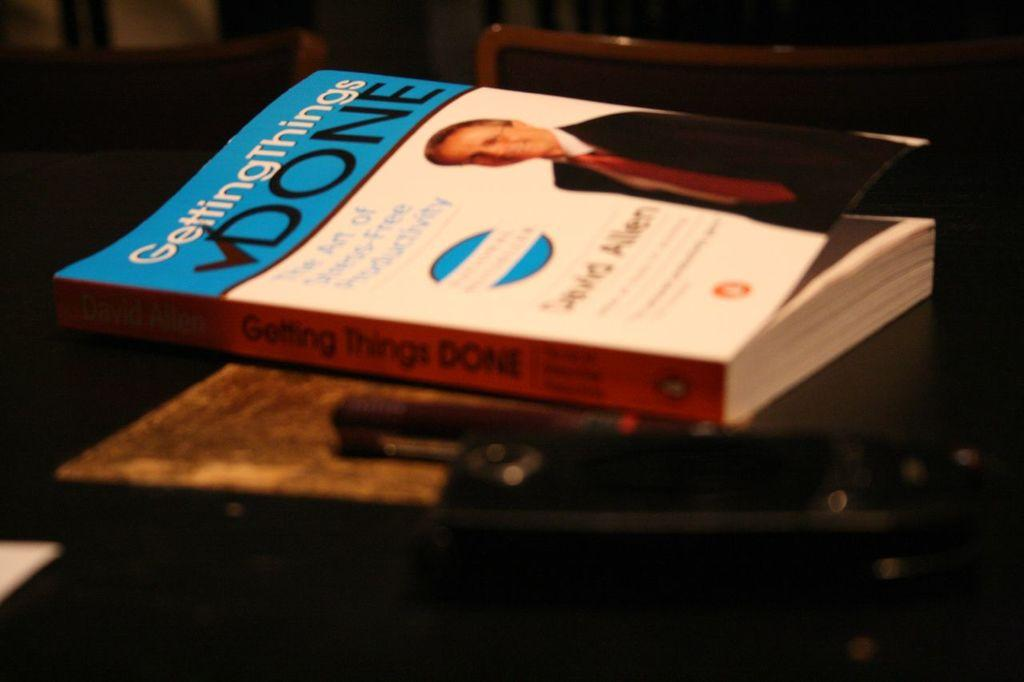Provide a one-sentence caption for the provided image. "GettingThings Done", is the title of the book on the table. 